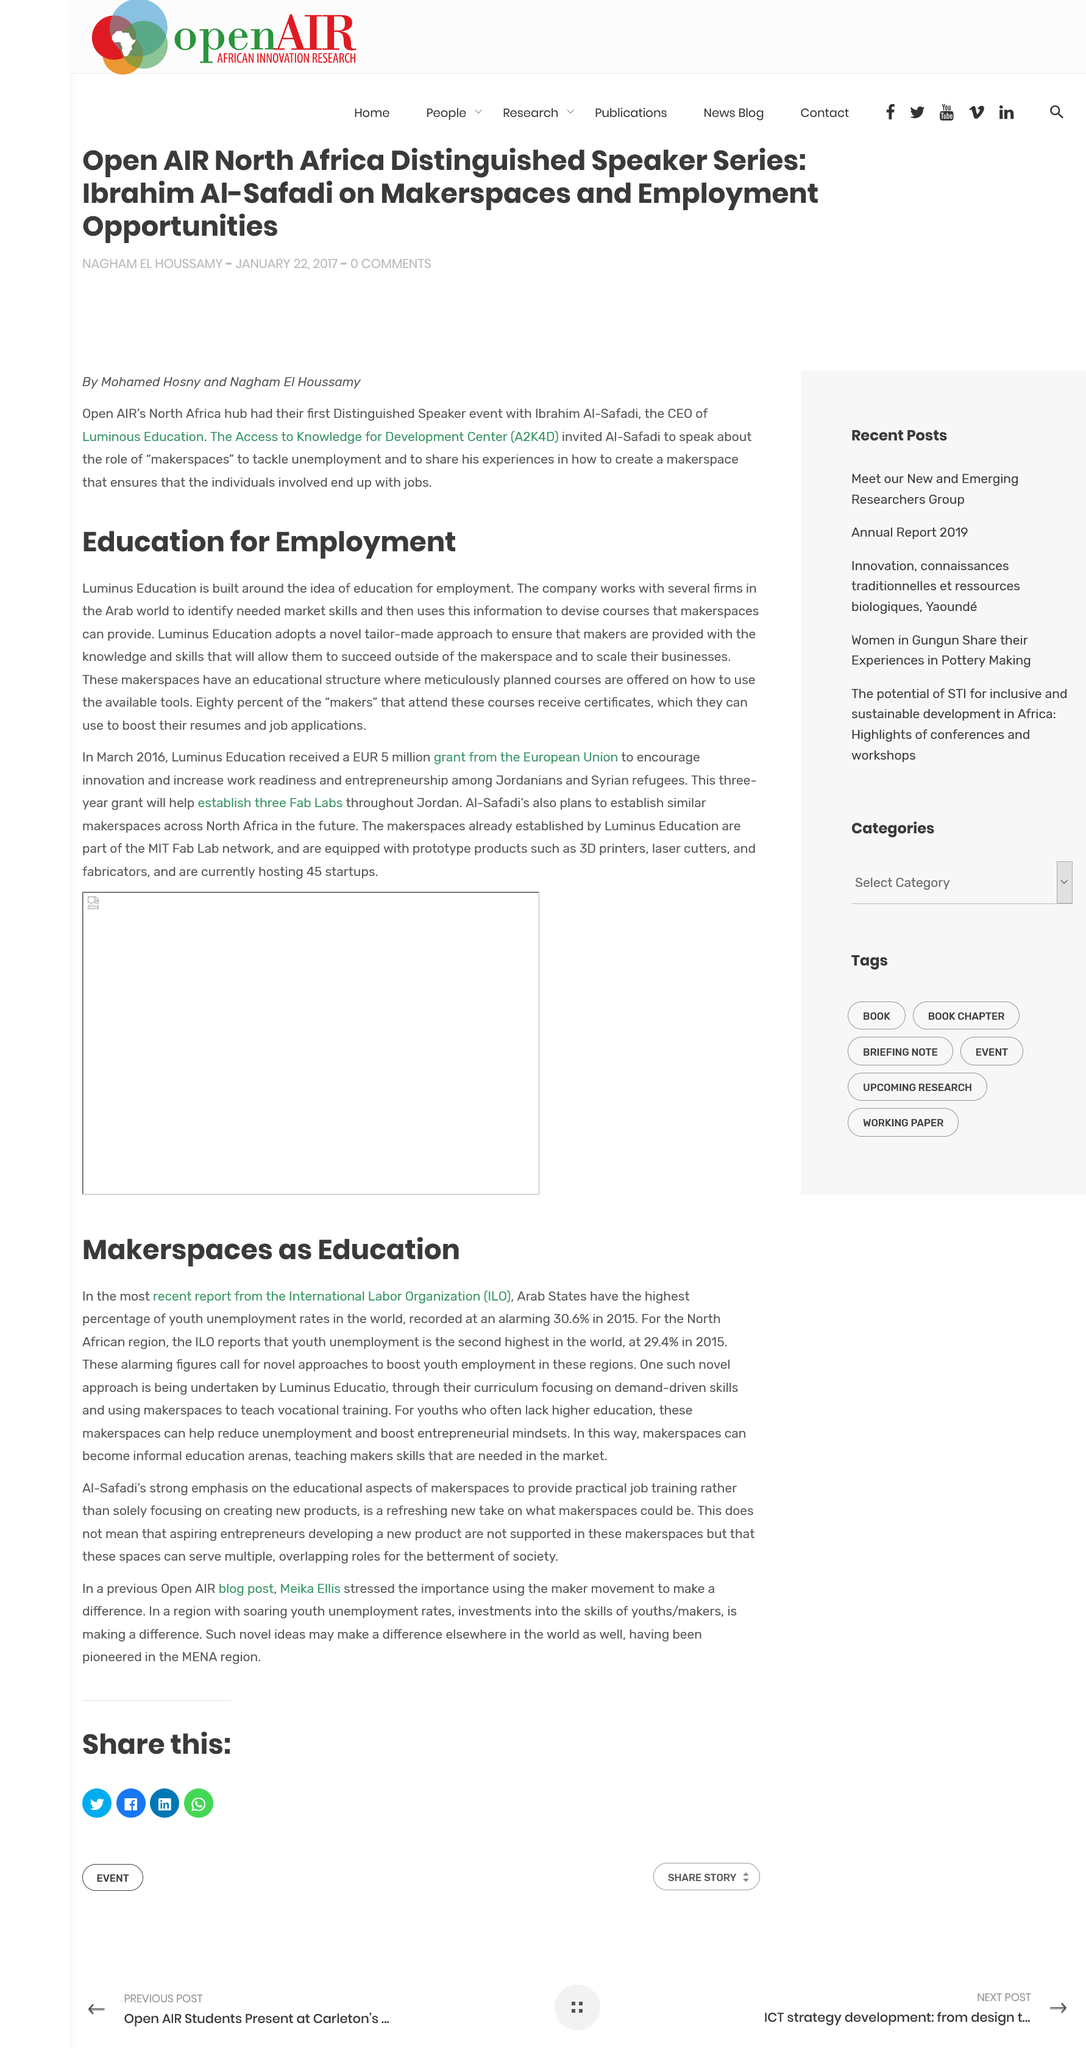List a handful of essential elements in this visual. Luminus Education is a company that is dedicated to providing education for the purpose of securing employment for its students. The company collaborates with several firms in the Arab world. Eighty percent of the "makers" who attend the courses receive certificates. Luminus Education is taking a novel approach to boost youth employment in the region by developing curriculum and teaching vocational training. The youth unemployment rate in the Arab States is an alarming 30.6% in 2015, according to a recent report. 